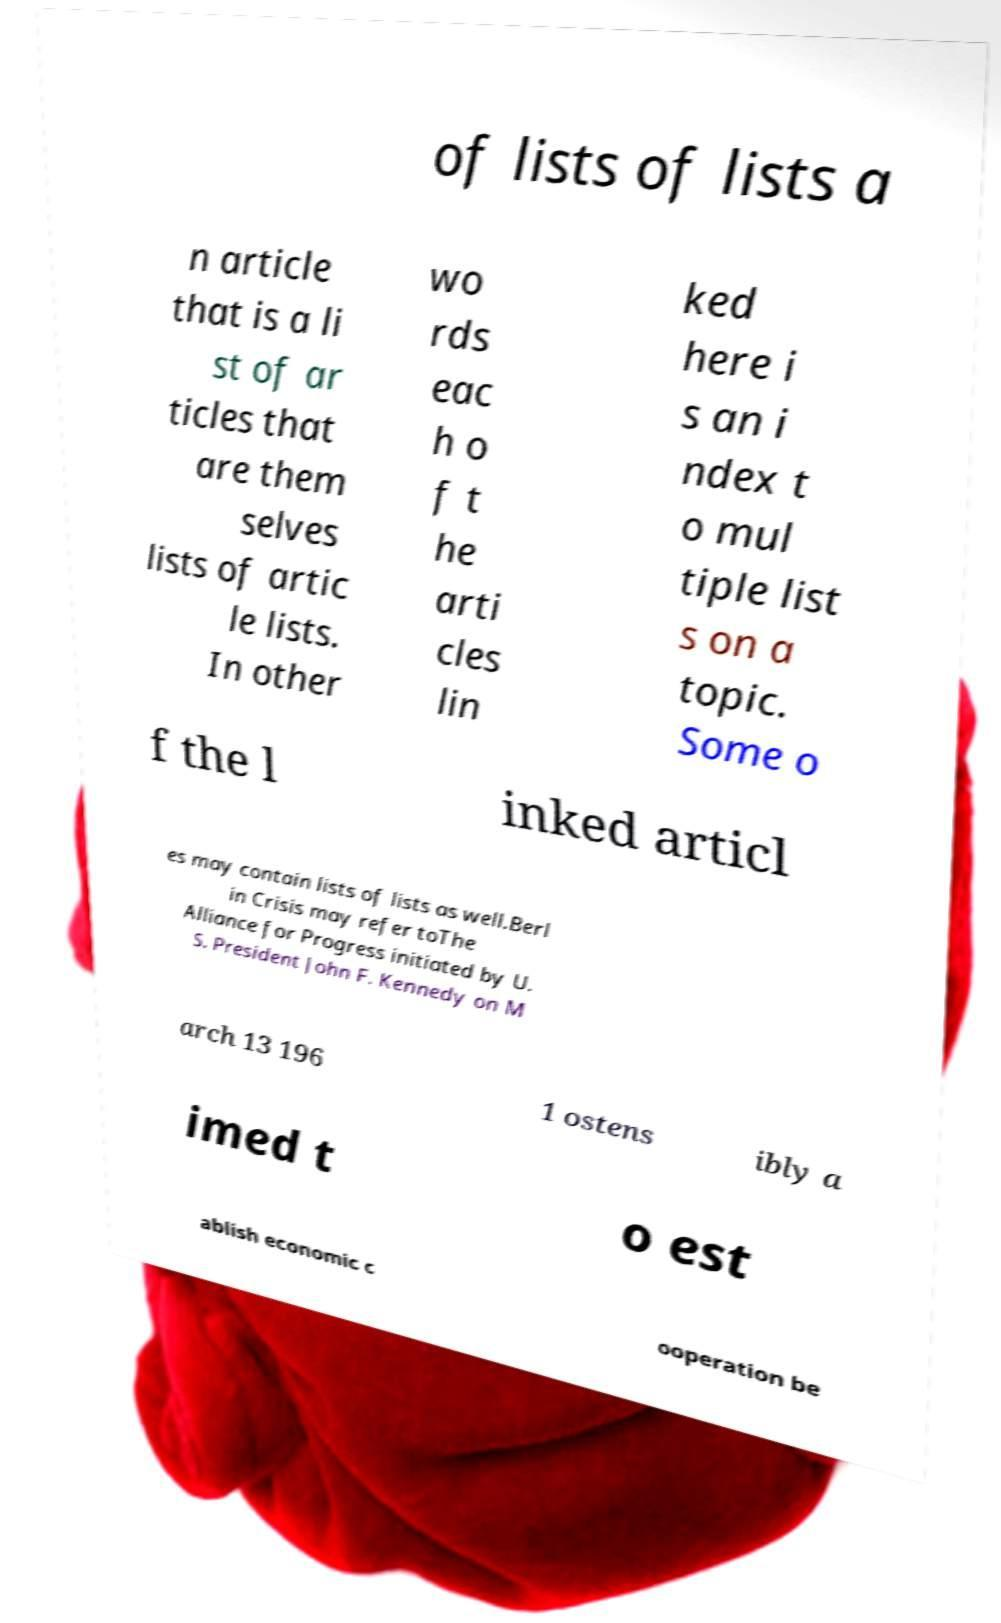For documentation purposes, I need the text within this image transcribed. Could you provide that? of lists of lists a n article that is a li st of ar ticles that are them selves lists of artic le lists. In other wo rds eac h o f t he arti cles lin ked here i s an i ndex t o mul tiple list s on a topic. Some o f the l inked articl es may contain lists of lists as well.Berl in Crisis may refer toThe Alliance for Progress initiated by U. S. President John F. Kennedy on M arch 13 196 1 ostens ibly a imed t o est ablish economic c ooperation be 